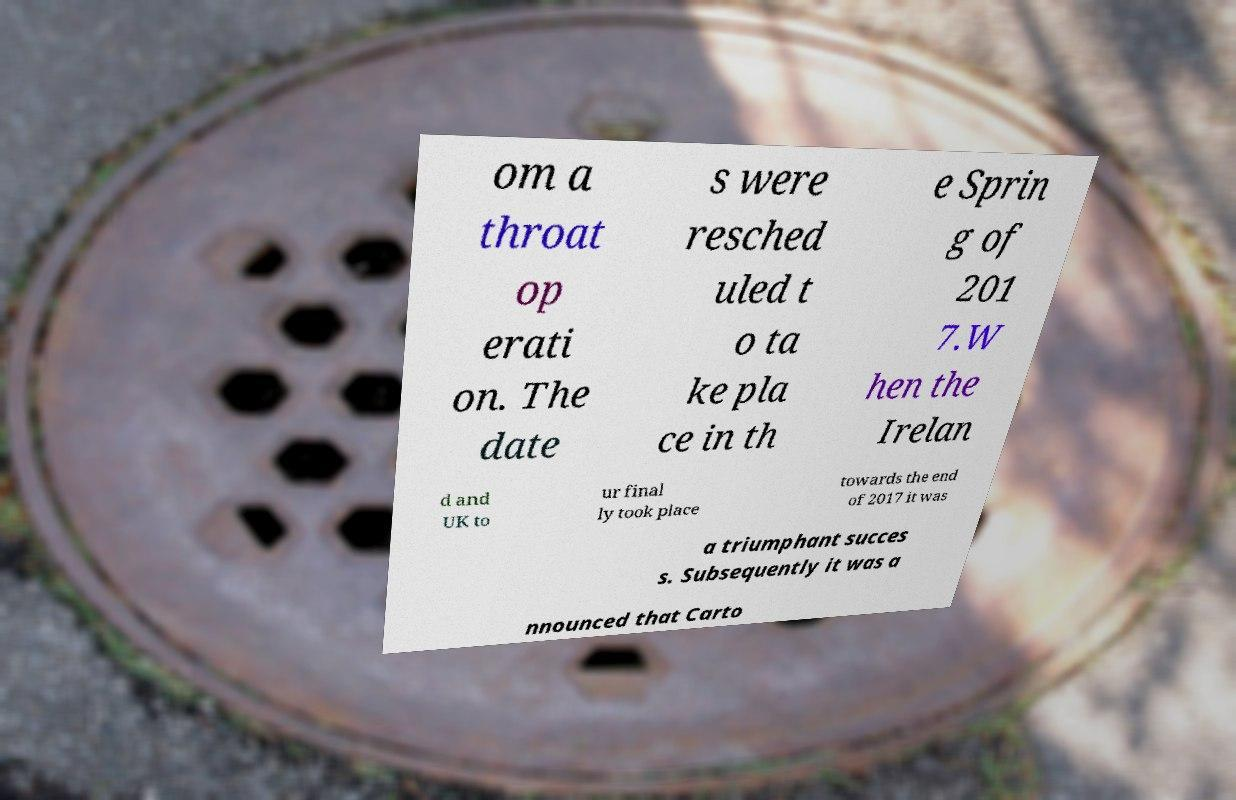What messages or text are displayed in this image? I need them in a readable, typed format. om a throat op erati on. The date s were resched uled t o ta ke pla ce in th e Sprin g of 201 7.W hen the Irelan d and UK to ur final ly took place towards the end of 2017 it was a triumphant succes s. Subsequently it was a nnounced that Carto 